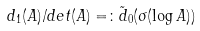<formula> <loc_0><loc_0><loc_500><loc_500>d _ { 1 } ( A ) / d e t ( A ) = \colon \tilde { d } _ { 0 } ( \sigma ( \log A ) )</formula> 